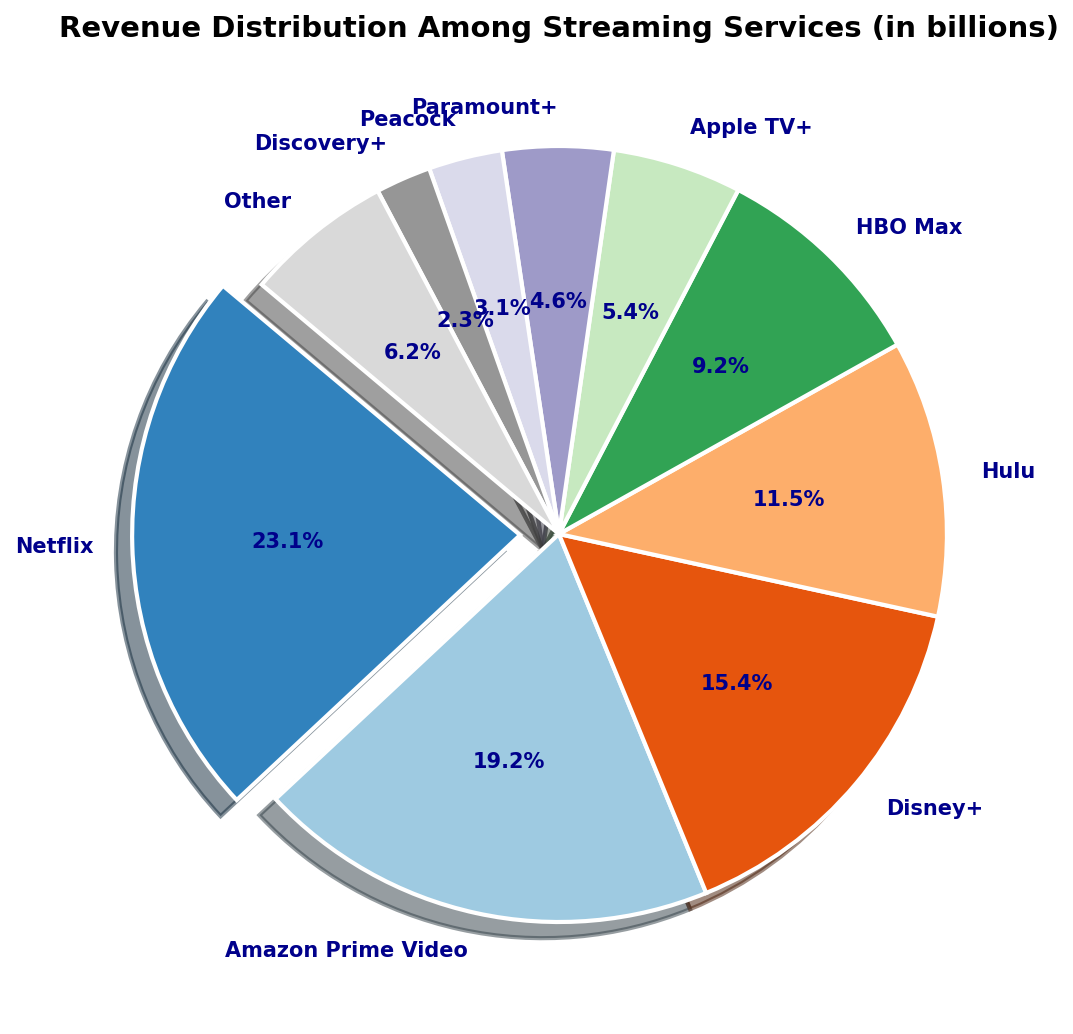What percentage of total revenue does Netflix contribute? The slice representing Netflix shows a value of 30.0 billion. The pie chart indicates that Netflix contributes the largest portion, and the percentage is explicitly shown near the slice.
Answer: 30.0% Which streaming service has the smallest revenue share, and what is its percentage? The slice with the smallest size is marked as Discovery+, and the percentage value is displayed next to it.
Answer: Discovery+, 3.0% What is the combined revenue percentage of Hulu and Disney+? The individual percentages for Hulu and Disney+ are shown in the pie chart. Adding them together gives: Hulu (15.0%) + Disney+ (20.0%) = 35.0%.
Answer: 35.0% Between Apple TV+ and HBO Max, which service has a higher revenue, and by how much? By comparing the sizes of the respective slices, it is clear that HBO Max has a higher revenue. The difference between HBO Max (12.0 billion) and Apple TV+ (7.0 billion) is 5.0 billion.
Answer: HBO Max, 5.0 billion Group the services generating less than 10 billion in revenue and compute their total revenue percentage. The services Discovery+ (3.0%), Peacock (4.0%), Paramount+ (6.0%), and Apple TV+ (7.0%) all have revenues less than 10 billion. Adding their contributions: 3% + 4% + 6% + 7% = 20%.
Answer: 20% Which streaming service's slice is highlighted (exploded) and why? The pie chart has one slice exploded for emphasis, which is Netflix. It is done to highlight that Netflix has the highest revenue share.
Answer: Netflix What is the revenue difference between the highest and the lowest earning streaming services? The highest earning service is Netflix (30.0 billion) and the lowest is Discovery+ (3.0 billion). The difference is calculated by subtracting the two: 30.0 billion - 3.0 billion = 27.0 billion.
Answer: 27.0 billion What is the combined revenue of Amazon Prime Video and HBO Max? By summing up the individual revenues of Amazon Prime Video (25.0 billion) and HBO Max (12.0 billion), the combined revenue is: 25.0 billion + 12.0 billion = 37.0 billion.
Answer: 37.0 billion 